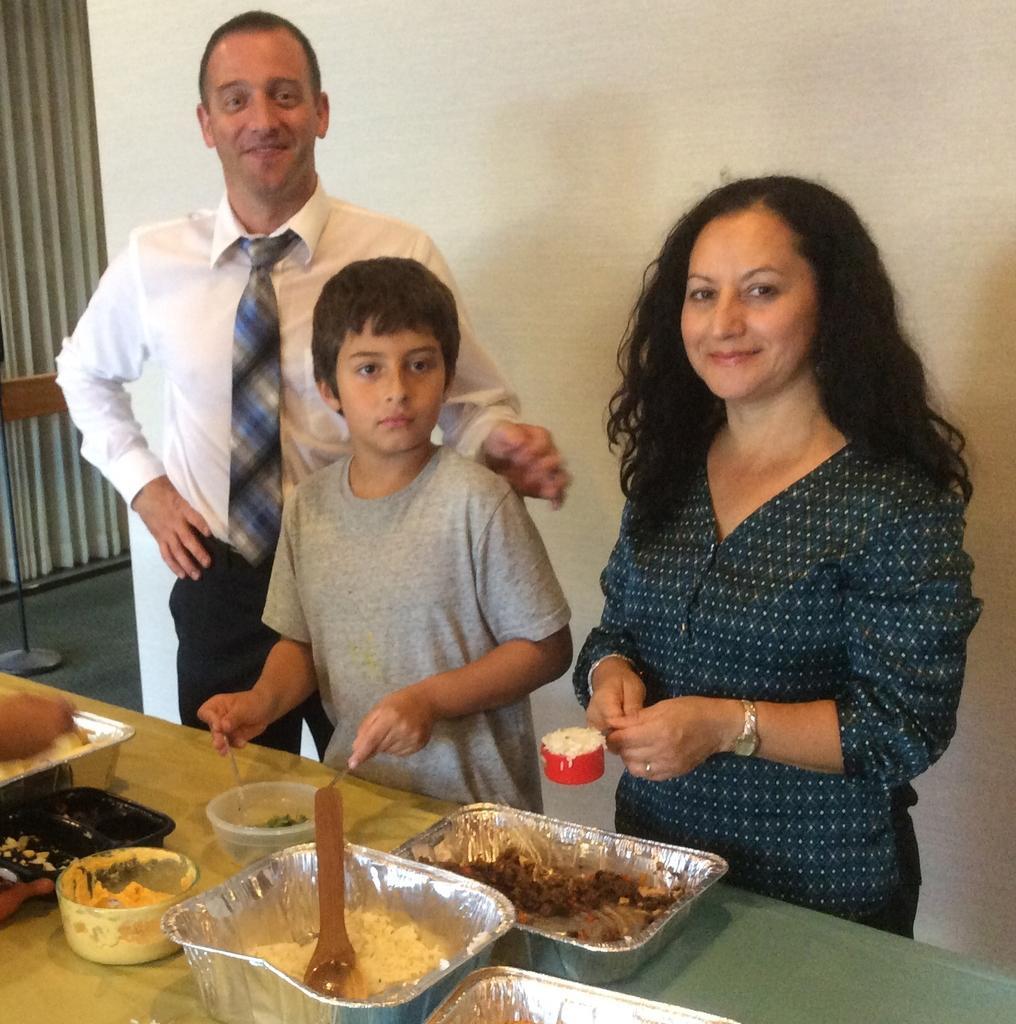Describe this image in one or two sentences. In this image I can see three persons are standing on the floor in front of a table on which boxes, trays, bowl and food items are kept. In the background I can see a wall and door. This image is taken may be in a room. 